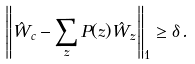Convert formula to latex. <formula><loc_0><loc_0><loc_500><loc_500>\left \| \hat { W } _ { c } - \sum _ { z } P ( z ) \hat { W } _ { z } \right \| _ { 1 } \geq \delta \, .</formula> 